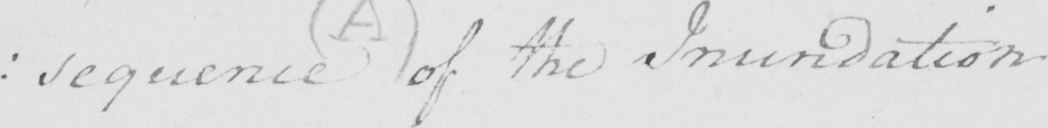Can you tell me what this handwritten text says? : sequence of the Inundation . 